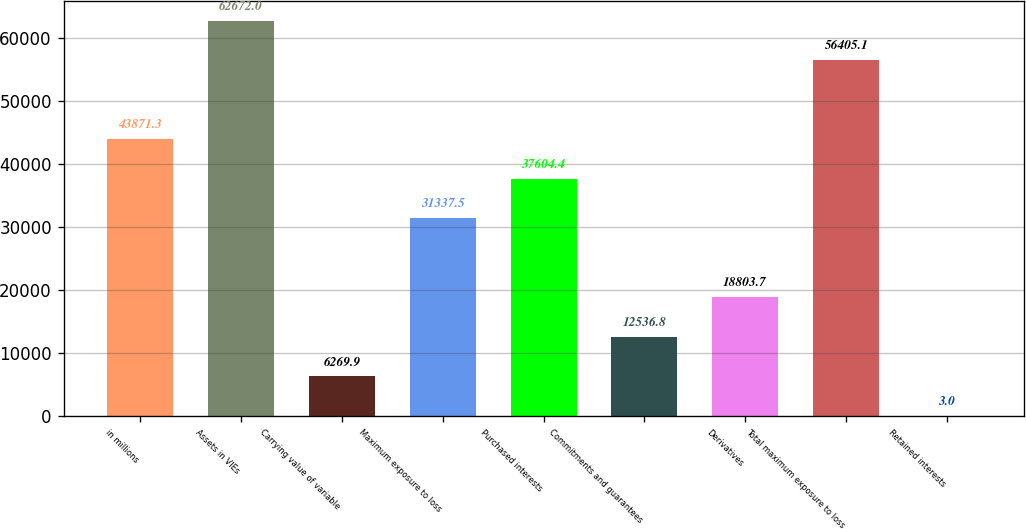Convert chart. <chart><loc_0><loc_0><loc_500><loc_500><bar_chart><fcel>in millions<fcel>Assets in VIEs<fcel>Carrying value of variable<fcel>Maximum exposure to loss<fcel>Purchased interests<fcel>Commitments and guarantees<fcel>Derivatives<fcel>Total maximum exposure to loss<fcel>Retained interests<nl><fcel>43871.3<fcel>62672<fcel>6269.9<fcel>31337.5<fcel>37604.4<fcel>12536.8<fcel>18803.7<fcel>56405.1<fcel>3<nl></chart> 